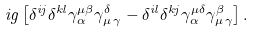Convert formula to latex. <formula><loc_0><loc_0><loc_500><loc_500>i g \left [ \delta ^ { i j } \delta ^ { k l } \gamma _ { \alpha } ^ { \mu \beta } \gamma _ { \mu \, \gamma } ^ { \delta } - \delta ^ { i l } \delta ^ { k j } \gamma _ { \alpha } ^ { \mu \delta } \gamma _ { \mu \, \gamma } ^ { \beta } \right ] .</formula> 